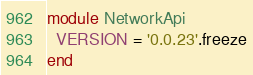<code> <loc_0><loc_0><loc_500><loc_500><_Ruby_>module NetworkApi
  VERSION = '0.0.23'.freeze
end
</code> 